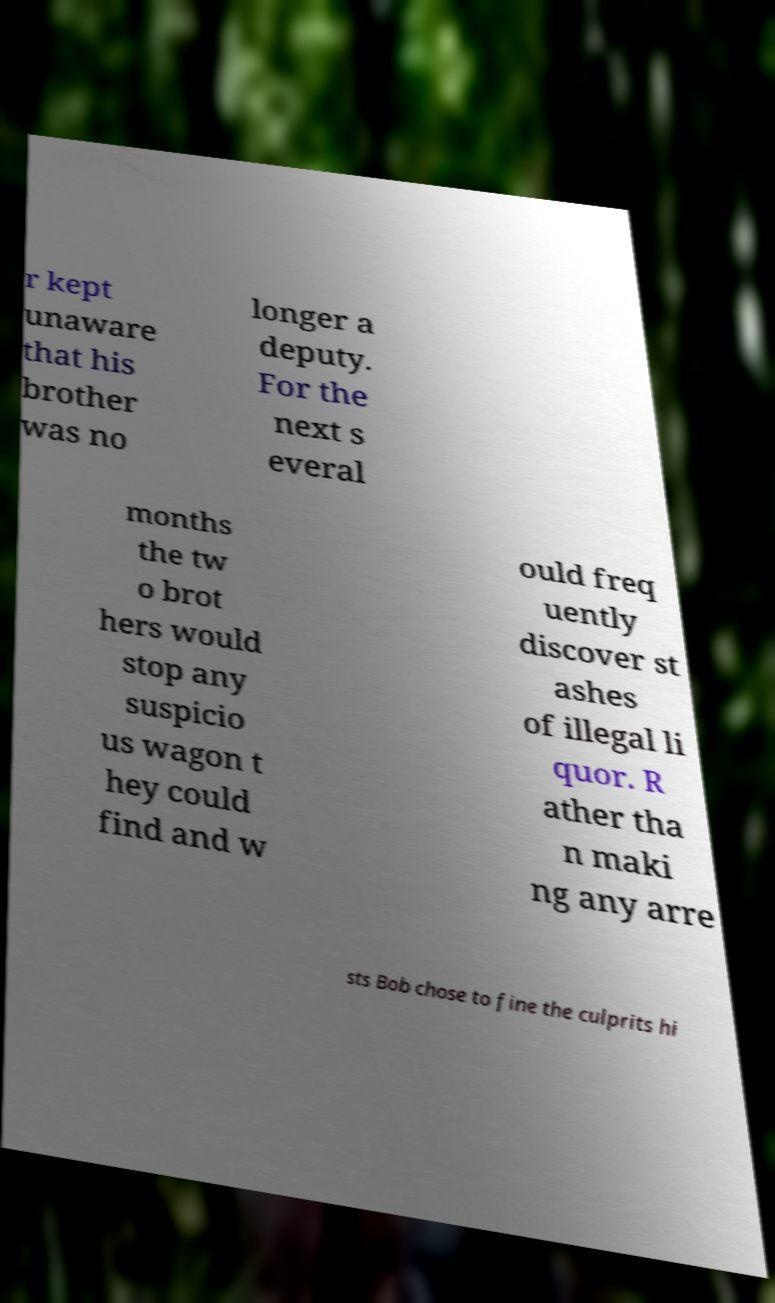Can you read and provide the text displayed in the image?This photo seems to have some interesting text. Can you extract and type it out for me? r kept unaware that his brother was no longer a deputy. For the next s everal months the tw o brot hers would stop any suspicio us wagon t hey could find and w ould freq uently discover st ashes of illegal li quor. R ather tha n maki ng any arre sts Bob chose to fine the culprits hi 